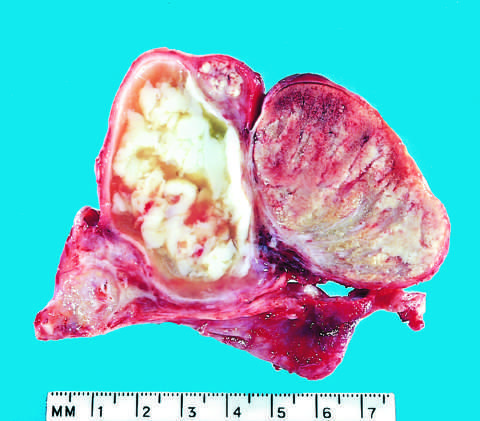where is normal testis seen?
Answer the question using a single word or phrase. On the right 